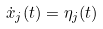<formula> <loc_0><loc_0><loc_500><loc_500>\dot { x } _ { j } ( t ) = \eta _ { j } ( t )</formula> 